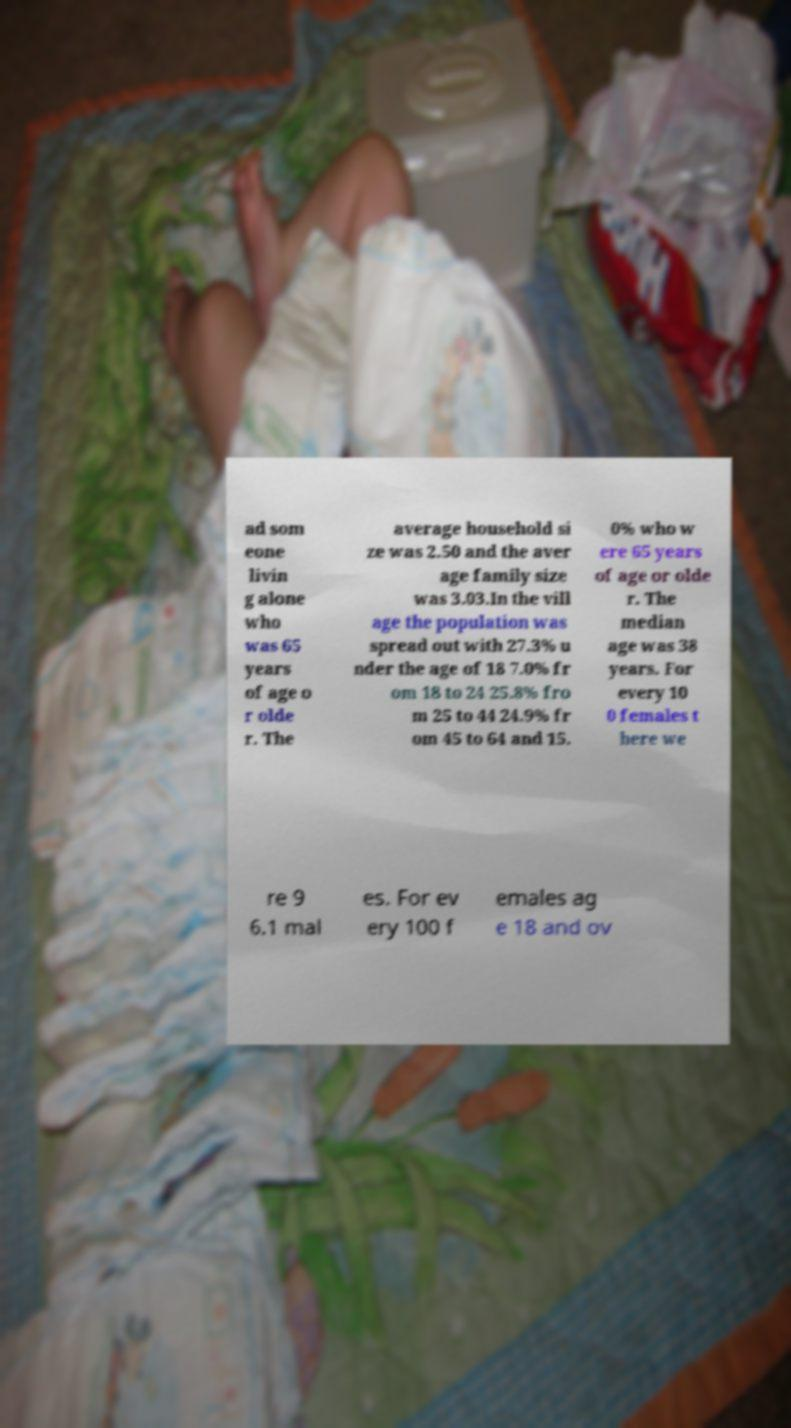There's text embedded in this image that I need extracted. Can you transcribe it verbatim? ad som eone livin g alone who was 65 years of age o r olde r. The average household si ze was 2.50 and the aver age family size was 3.03.In the vill age the population was spread out with 27.3% u nder the age of 18 7.0% fr om 18 to 24 25.8% fro m 25 to 44 24.9% fr om 45 to 64 and 15. 0% who w ere 65 years of age or olde r. The median age was 38 years. For every 10 0 females t here we re 9 6.1 mal es. For ev ery 100 f emales ag e 18 and ov 